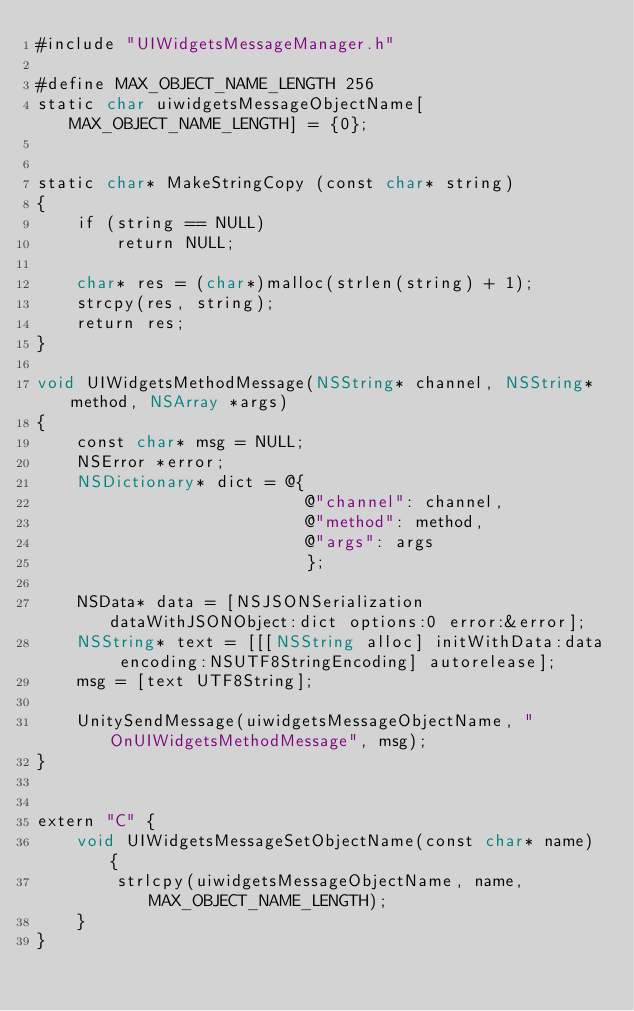<code> <loc_0><loc_0><loc_500><loc_500><_ObjectiveC_>#include "UIWidgetsMessageManager.h"

#define MAX_OBJECT_NAME_LENGTH 256
static char uiwidgetsMessageObjectName[MAX_OBJECT_NAME_LENGTH] = {0};


static char* MakeStringCopy (const char* string)
{
    if (string == NULL)
        return NULL;
    
    char* res = (char*)malloc(strlen(string) + 1);
    strcpy(res, string);
    return res;
}

void UIWidgetsMethodMessage(NSString* channel, NSString* method, NSArray *args)
{
    const char* msg = NULL;
    NSError *error;
    NSDictionary* dict = @{
                           @"channel": channel,
                           @"method": method,
                           @"args": args
                           };
   
    NSData* data = [NSJSONSerialization dataWithJSONObject:dict options:0 error:&error];
    NSString* text = [[[NSString alloc] initWithData:data encoding:NSUTF8StringEncoding] autorelease];
    msg = [text UTF8String];
    
    UnitySendMessage(uiwidgetsMessageObjectName, "OnUIWidgetsMethodMessage", msg);
}


extern "C" {
    void UIWidgetsMessageSetObjectName(const char* name) {
        strlcpy(uiwidgetsMessageObjectName, name, MAX_OBJECT_NAME_LENGTH);
    }
}
</code> 